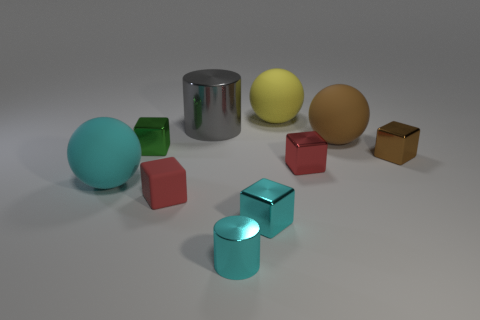Do the small brown thing and the green metal thing have the same shape?
Provide a short and direct response. Yes. What material is the large object that is in front of the tiny thing that is on the left side of the red matte block?
Offer a terse response. Rubber. Are there fewer brown matte spheres that are right of the large brown thing than objects in front of the cyan matte thing?
Offer a terse response. Yes. There is a big thing that is the same color as the small metal cylinder; what is it made of?
Ensure brevity in your answer.  Rubber. What is the sphere left of the tiny cylinder made of?
Ensure brevity in your answer.  Rubber. There is a green metallic thing; are there any large matte objects in front of it?
Keep it short and to the point. Yes. There is a big yellow thing; what shape is it?
Offer a very short reply. Sphere. How many objects are either tiny objects that are left of the tiny red rubber thing or cyan matte objects?
Your answer should be compact. 2. What number of other things are there of the same color as the tiny cylinder?
Make the answer very short. 2. Is the color of the tiny cylinder the same as the matte ball in front of the big brown sphere?
Offer a terse response. Yes. 